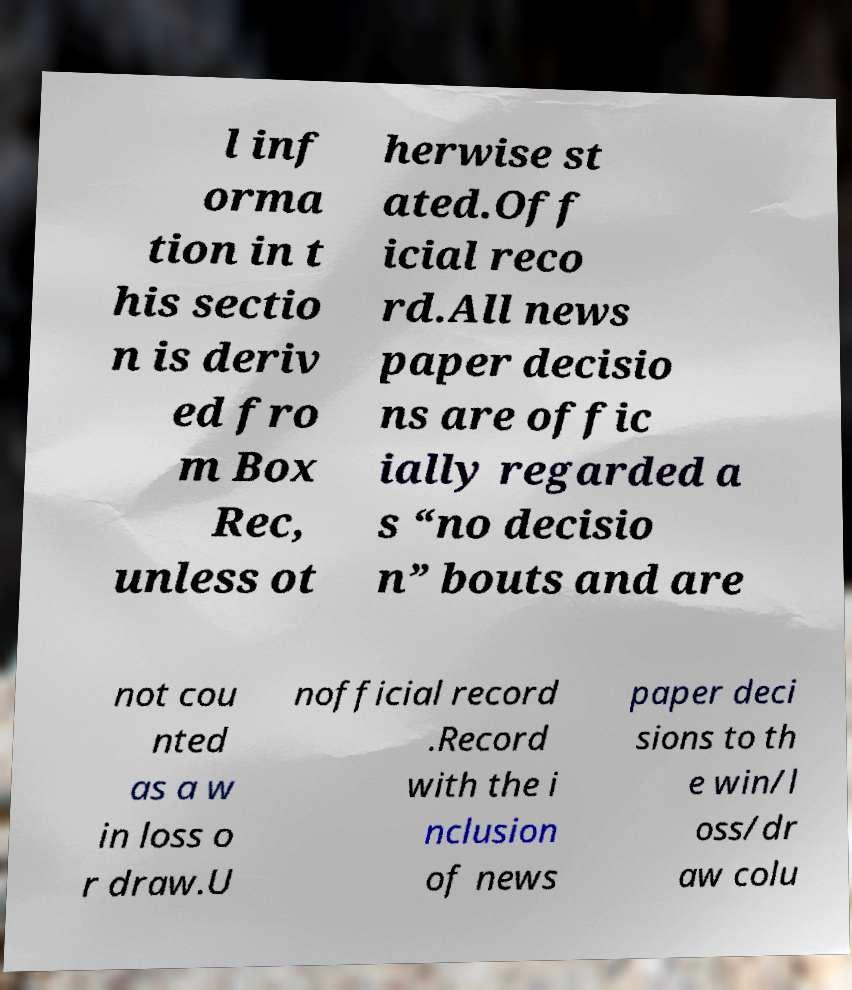I need the written content from this picture converted into text. Can you do that? l inf orma tion in t his sectio n is deriv ed fro m Box Rec, unless ot herwise st ated.Off icial reco rd.All news paper decisio ns are offic ially regarded a s “no decisio n” bouts and are not cou nted as a w in loss o r draw.U nofficial record .Record with the i nclusion of news paper deci sions to th e win/l oss/dr aw colu 